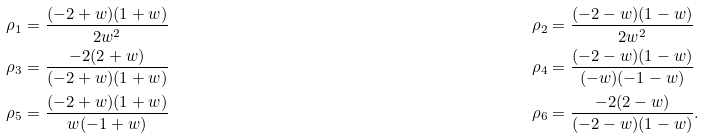<formula> <loc_0><loc_0><loc_500><loc_500>\rho _ { 1 } & = \frac { ( - 2 + w ) ( 1 + w ) } { 2 w ^ { 2 } } & \quad \rho _ { 2 } & = \frac { ( - 2 - w ) ( 1 - w ) } { 2 w ^ { 2 } } \\ \rho _ { 3 } & = \frac { - 2 ( 2 + w ) } { ( - 2 + w ) ( 1 + w ) } & \quad \rho _ { 4 } & = \frac { ( - 2 - w ) ( 1 - w ) } { ( - w ) ( - 1 - w ) } \\ \rho _ { 5 } & = \frac { ( - 2 + w ) ( 1 + w ) } { w ( - 1 + w ) } & \quad \rho _ { 6 } & = \frac { - 2 ( 2 - w ) } { ( - 2 - w ) ( 1 - w ) } .</formula> 